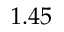<formula> <loc_0><loc_0><loc_500><loc_500>1 . 4 5</formula> 